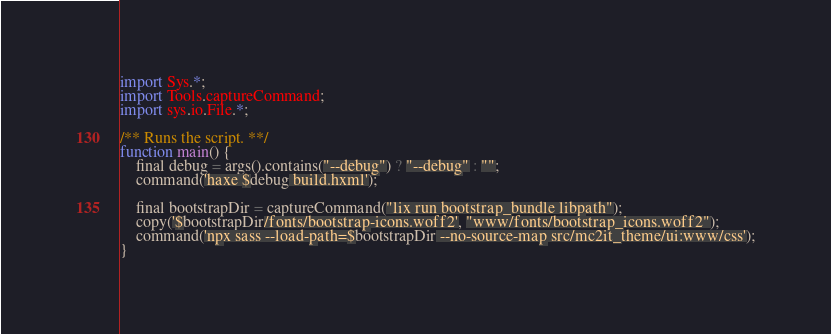<code> <loc_0><loc_0><loc_500><loc_500><_Haxe_>import Sys.*;
import Tools.captureCommand;
import sys.io.File.*;

/** Runs the script. **/
function main() {
	final debug = args().contains("--debug") ? "--debug" : "";
	command('haxe $debug build.hxml');

	final bootstrapDir = captureCommand("lix run bootstrap_bundle libpath");
	copy('$bootstrapDir/fonts/bootstrap-icons.woff2', "www/fonts/bootstrap_icons.woff2");
	command('npx sass --load-path=$bootstrapDir --no-source-map src/mc2it_theme/ui:www/css');
}
</code> 